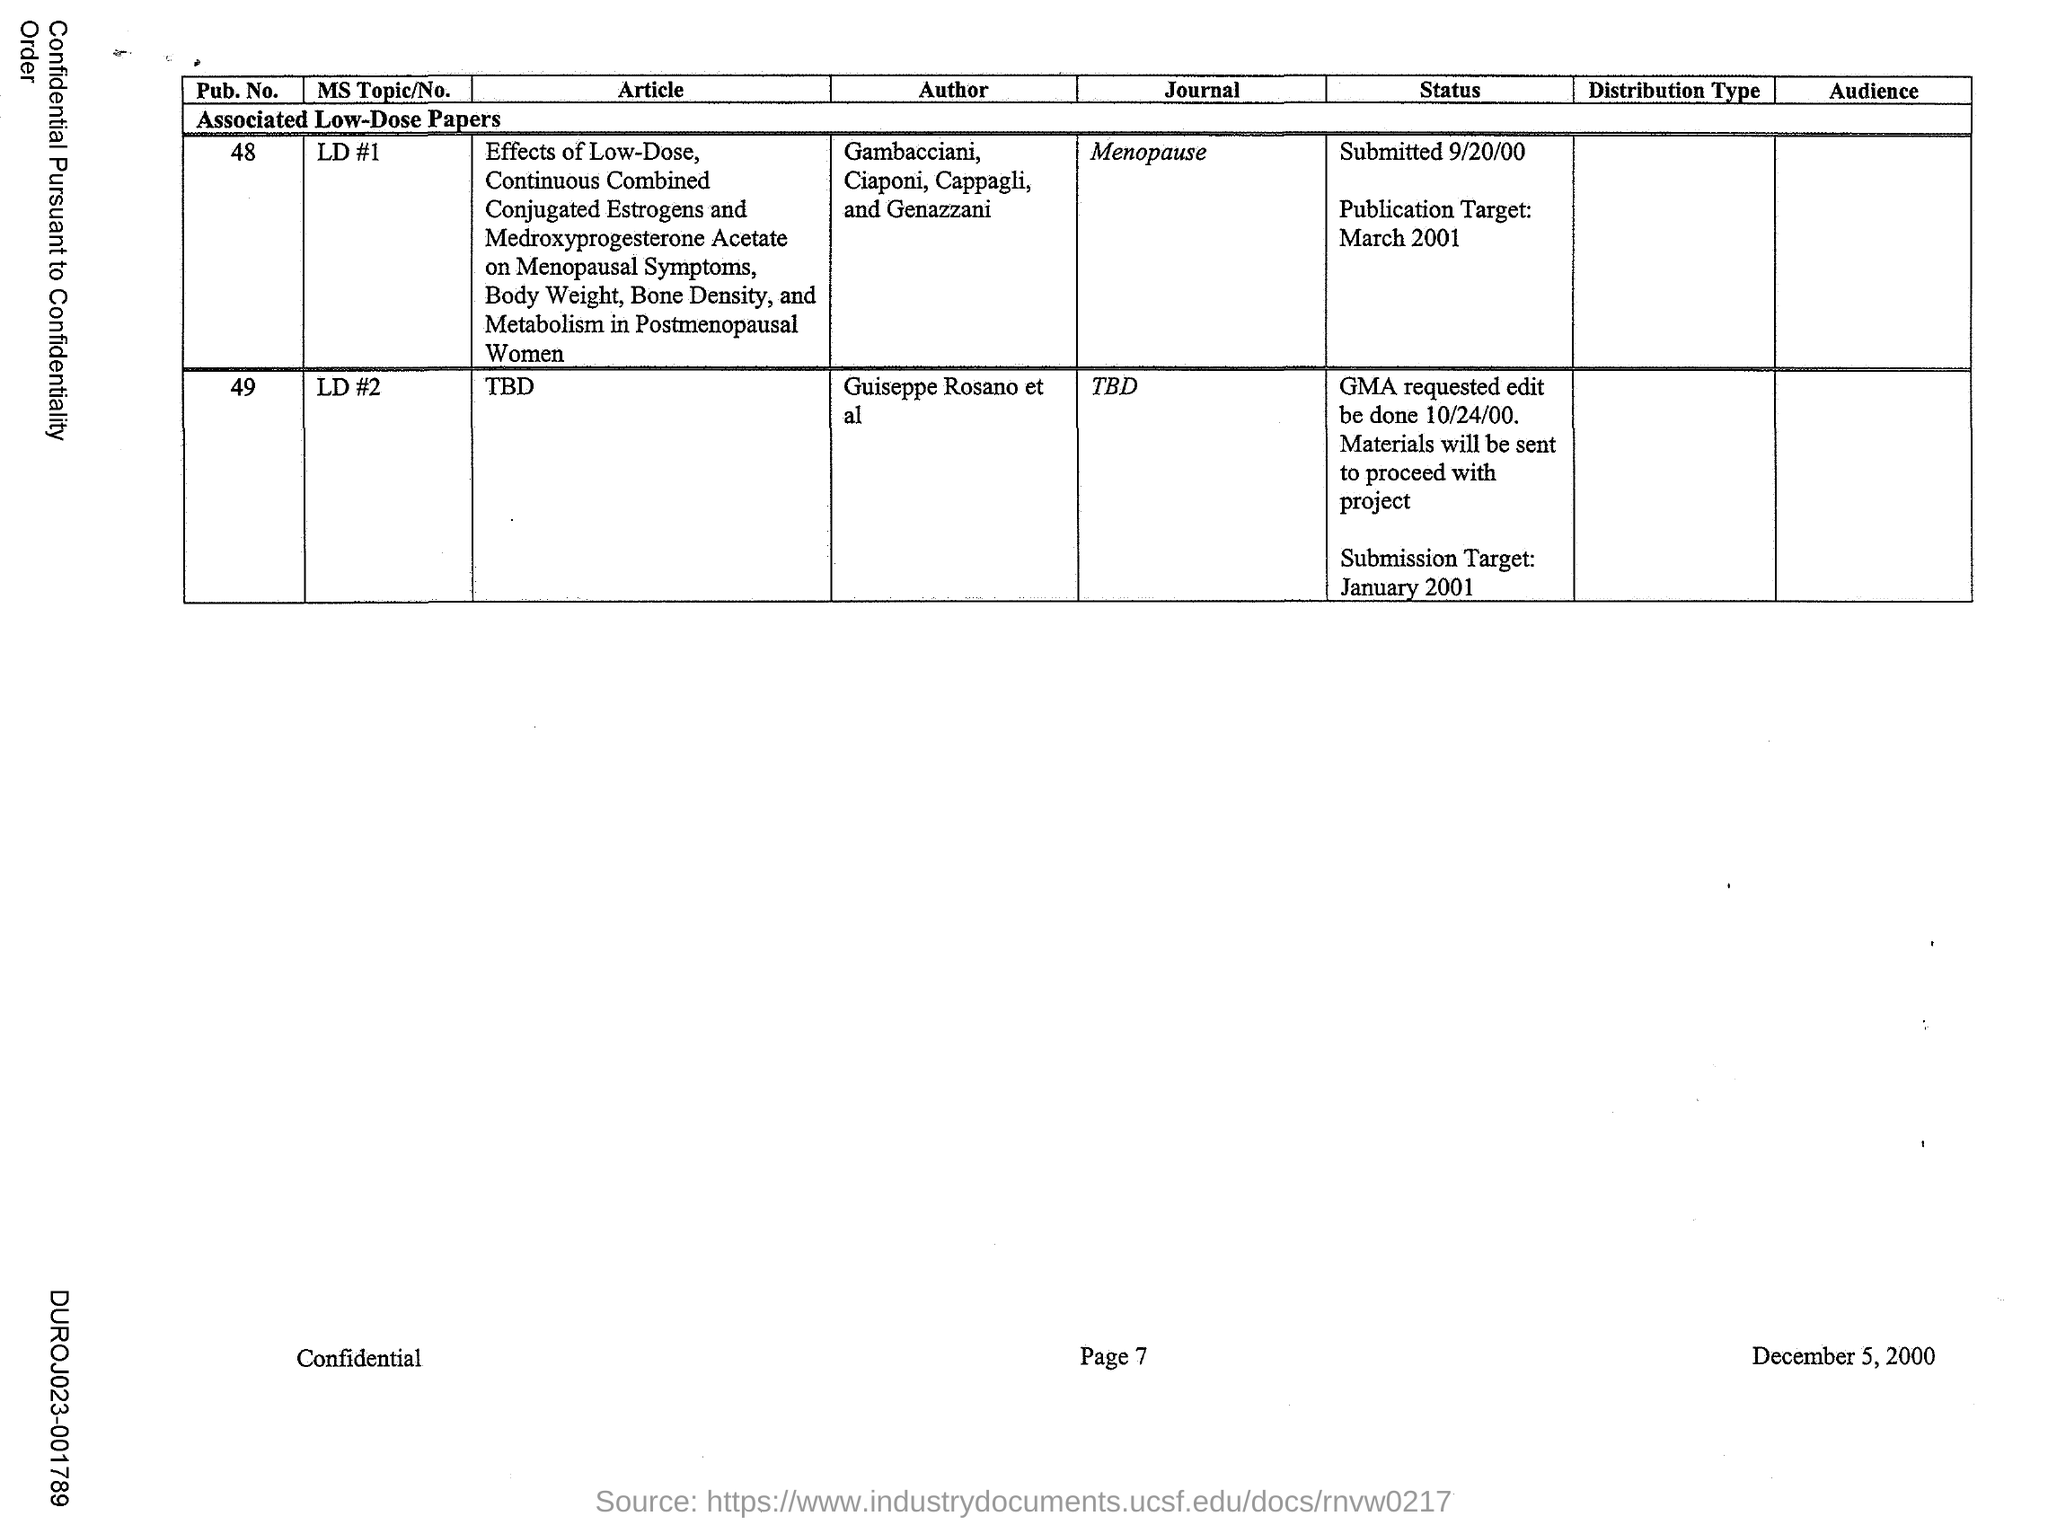Specify some key components in this picture. The journal associated with Pub No. 48 is "Menopause. The Pub No. 49 is associated with a journal that has not yet been determined. 